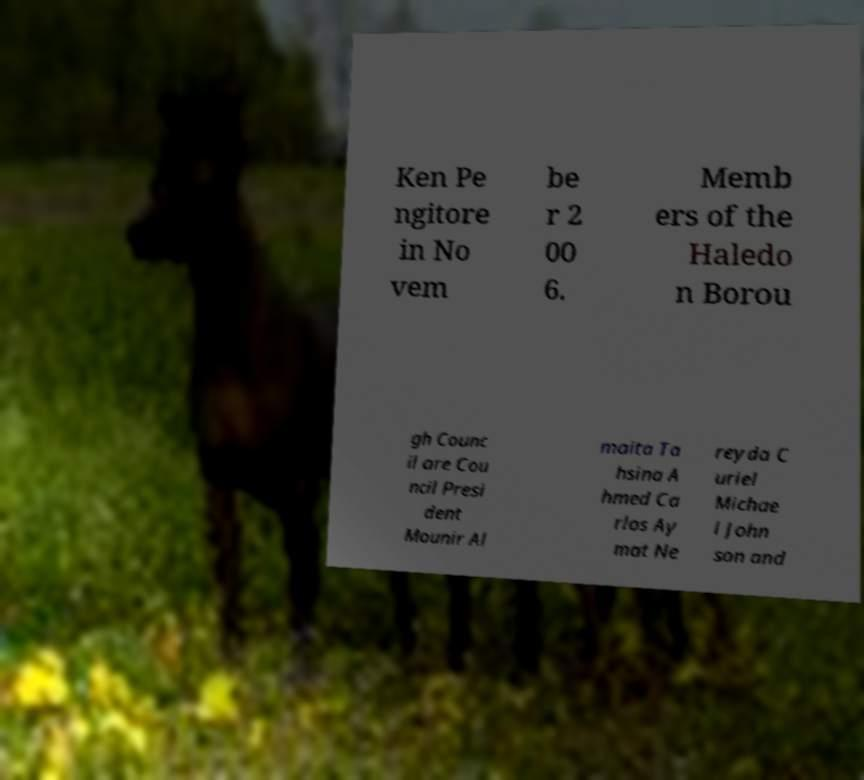Can you read and provide the text displayed in the image?This photo seems to have some interesting text. Can you extract and type it out for me? Ken Pe ngitore in No vem be r 2 00 6. Memb ers of the Haledo n Borou gh Counc il are Cou ncil Presi dent Mounir Al maita Ta hsina A hmed Ca rlos Ay mat Ne reyda C uriel Michae l John son and 